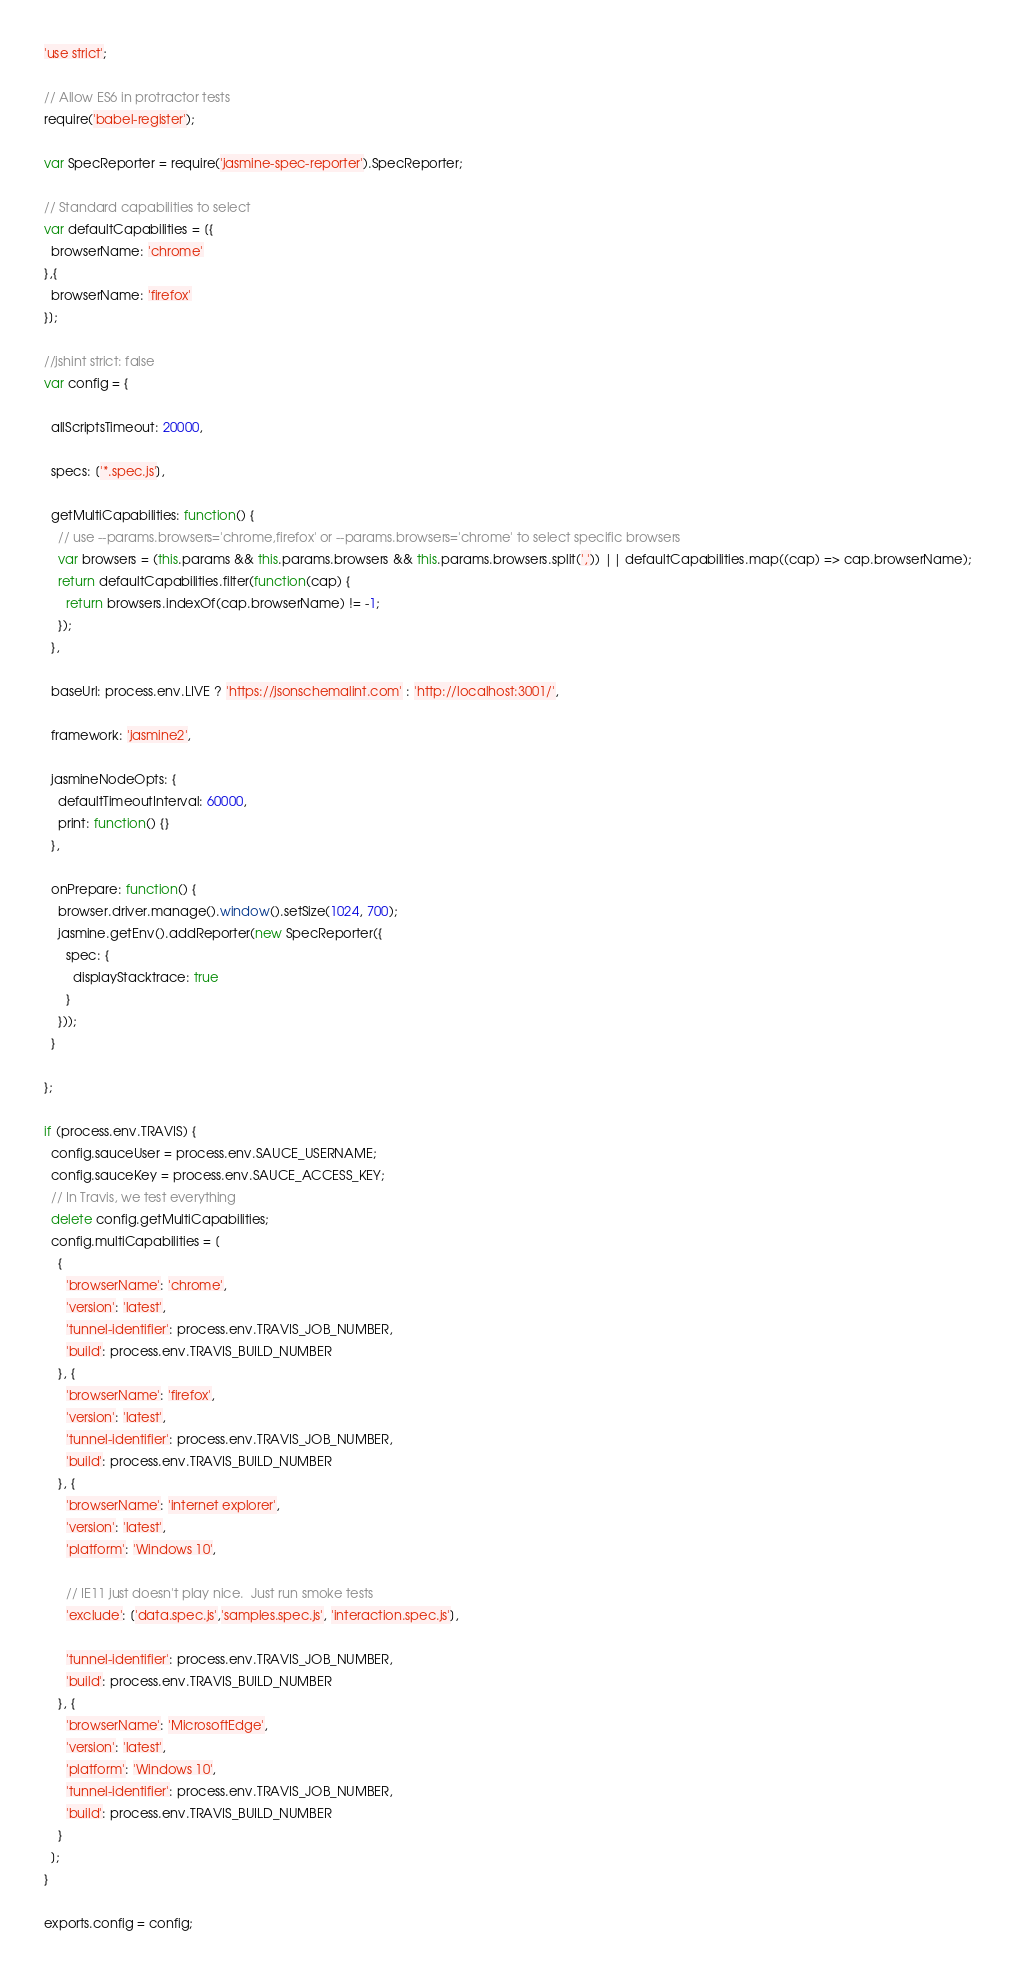<code> <loc_0><loc_0><loc_500><loc_500><_JavaScript_>'use strict';

// Allow ES6 in protractor tests
require('babel-register');

var SpecReporter = require('jasmine-spec-reporter').SpecReporter;

// Standard capabilities to select
var defaultCapabilities = [{
  browserName: 'chrome'
},{
  browserName: 'firefox'
}];

//jshint strict: false
var config = {

  allScriptsTimeout: 20000,

  specs: ['*.spec.js'],

  getMultiCapabilities: function() {
    // use --params.browsers='chrome,firefox' or --params.browsers='chrome' to select specific browsers
    var browsers = (this.params && this.params.browsers && this.params.browsers.split(',')) || defaultCapabilities.map((cap) => cap.browserName);
    return defaultCapabilities.filter(function(cap) {
      return browsers.indexOf(cap.browserName) != -1;
    });
  },

  baseUrl: process.env.LIVE ? 'https://jsonschemalint.com' : 'http://localhost:3001/',

  framework: 'jasmine2',

  jasmineNodeOpts: {
    defaultTimeoutInterval: 60000,
    print: function() {}
  },

  onPrepare: function() {
    browser.driver.manage().window().setSize(1024, 700);
    jasmine.getEnv().addReporter(new SpecReporter({
      spec: {
        displayStacktrace: true
      }
    }));
  }

};

if (process.env.TRAVIS) {
  config.sauceUser = process.env.SAUCE_USERNAME;
  config.sauceKey = process.env.SAUCE_ACCESS_KEY;
  // In Travis, we test everything
  delete config.getMultiCapabilities;
  config.multiCapabilities = [
    {
      'browserName': 'chrome',
      'version': 'latest',
      'tunnel-identifier': process.env.TRAVIS_JOB_NUMBER,
      'build': process.env.TRAVIS_BUILD_NUMBER
    }, {
      'browserName': 'firefox',
      'version': 'latest',
      'tunnel-identifier': process.env.TRAVIS_JOB_NUMBER,
      'build': process.env.TRAVIS_BUILD_NUMBER
    }, {
      'browserName': 'internet explorer',
      'version': 'latest',
      'platform': 'Windows 10',

      // IE11 just doesn't play nice.  Just run smoke tests
      'exclude': ['data.spec.js','samples.spec.js', 'interaction.spec.js'],

      'tunnel-identifier': process.env.TRAVIS_JOB_NUMBER,
      'build': process.env.TRAVIS_BUILD_NUMBER
    }, {
      'browserName': 'MicrosoftEdge',
      'version': 'latest',
      'platform': 'Windows 10',
      'tunnel-identifier': process.env.TRAVIS_JOB_NUMBER,
      'build': process.env.TRAVIS_BUILD_NUMBER
    }
  ];
}

exports.config = config;
</code> 